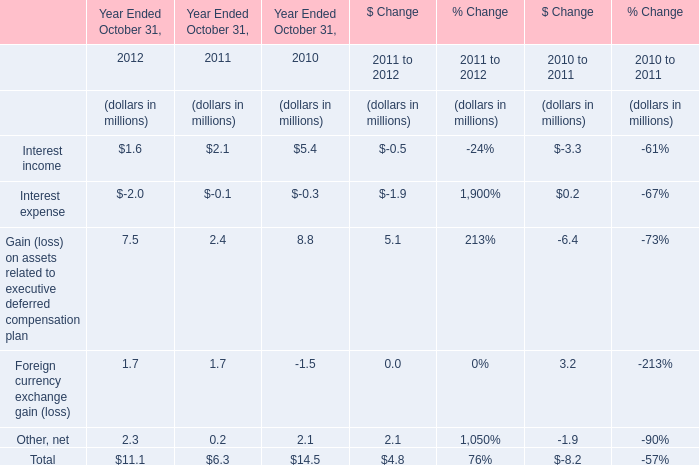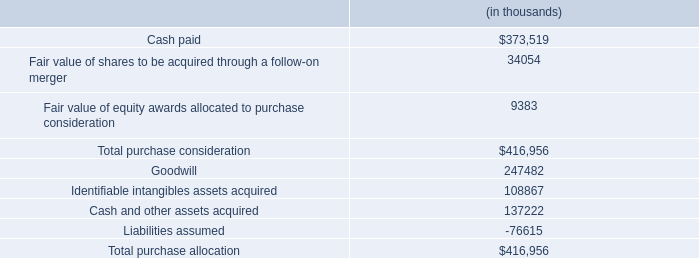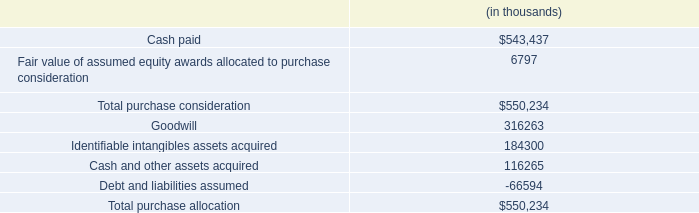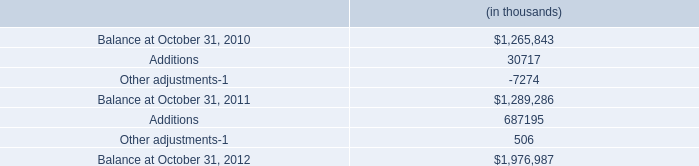In the year with the most Interest income, what is the growth rate of Total? 
Computations: ((6.3 - 14.5) / 14.5)
Answer: -0.56552. 